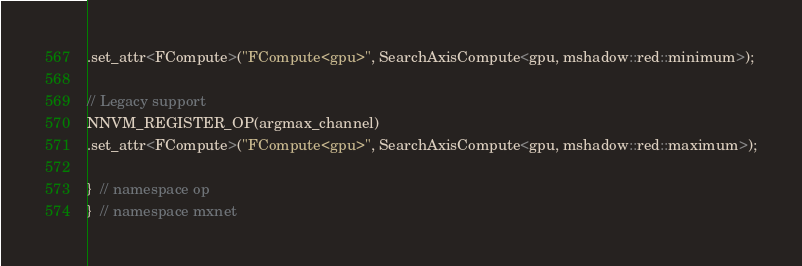Convert code to text. <code><loc_0><loc_0><loc_500><loc_500><_Cuda_>.set_attr<FCompute>("FCompute<gpu>", SearchAxisCompute<gpu, mshadow::red::minimum>);

// Legacy support
NNVM_REGISTER_OP(argmax_channel)
.set_attr<FCompute>("FCompute<gpu>", SearchAxisCompute<gpu, mshadow::red::maximum>);

}  // namespace op
}  // namespace mxnet
</code> 